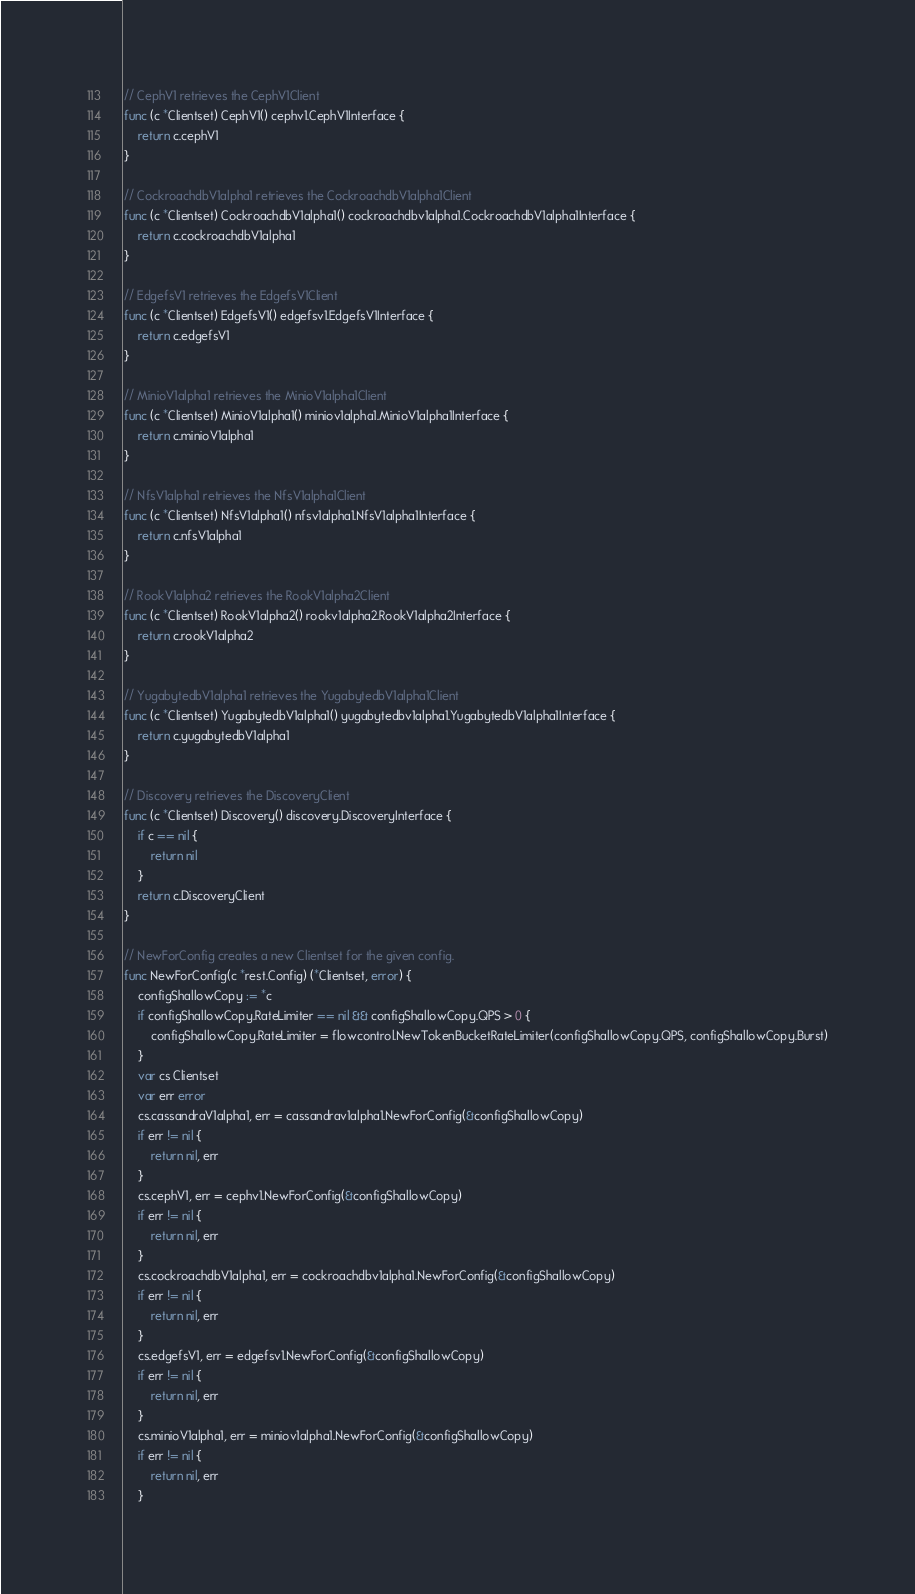<code> <loc_0><loc_0><loc_500><loc_500><_Go_>
// CephV1 retrieves the CephV1Client
func (c *Clientset) CephV1() cephv1.CephV1Interface {
	return c.cephV1
}

// CockroachdbV1alpha1 retrieves the CockroachdbV1alpha1Client
func (c *Clientset) CockroachdbV1alpha1() cockroachdbv1alpha1.CockroachdbV1alpha1Interface {
	return c.cockroachdbV1alpha1
}

// EdgefsV1 retrieves the EdgefsV1Client
func (c *Clientset) EdgefsV1() edgefsv1.EdgefsV1Interface {
	return c.edgefsV1
}

// MinioV1alpha1 retrieves the MinioV1alpha1Client
func (c *Clientset) MinioV1alpha1() miniov1alpha1.MinioV1alpha1Interface {
	return c.minioV1alpha1
}

// NfsV1alpha1 retrieves the NfsV1alpha1Client
func (c *Clientset) NfsV1alpha1() nfsv1alpha1.NfsV1alpha1Interface {
	return c.nfsV1alpha1
}

// RookV1alpha2 retrieves the RookV1alpha2Client
func (c *Clientset) RookV1alpha2() rookv1alpha2.RookV1alpha2Interface {
	return c.rookV1alpha2
}

// YugabytedbV1alpha1 retrieves the YugabytedbV1alpha1Client
func (c *Clientset) YugabytedbV1alpha1() yugabytedbv1alpha1.YugabytedbV1alpha1Interface {
	return c.yugabytedbV1alpha1
}

// Discovery retrieves the DiscoveryClient
func (c *Clientset) Discovery() discovery.DiscoveryInterface {
	if c == nil {
		return nil
	}
	return c.DiscoveryClient
}

// NewForConfig creates a new Clientset for the given config.
func NewForConfig(c *rest.Config) (*Clientset, error) {
	configShallowCopy := *c
	if configShallowCopy.RateLimiter == nil && configShallowCopy.QPS > 0 {
		configShallowCopy.RateLimiter = flowcontrol.NewTokenBucketRateLimiter(configShallowCopy.QPS, configShallowCopy.Burst)
	}
	var cs Clientset
	var err error
	cs.cassandraV1alpha1, err = cassandrav1alpha1.NewForConfig(&configShallowCopy)
	if err != nil {
		return nil, err
	}
	cs.cephV1, err = cephv1.NewForConfig(&configShallowCopy)
	if err != nil {
		return nil, err
	}
	cs.cockroachdbV1alpha1, err = cockroachdbv1alpha1.NewForConfig(&configShallowCopy)
	if err != nil {
		return nil, err
	}
	cs.edgefsV1, err = edgefsv1.NewForConfig(&configShallowCopy)
	if err != nil {
		return nil, err
	}
	cs.minioV1alpha1, err = miniov1alpha1.NewForConfig(&configShallowCopy)
	if err != nil {
		return nil, err
	}</code> 